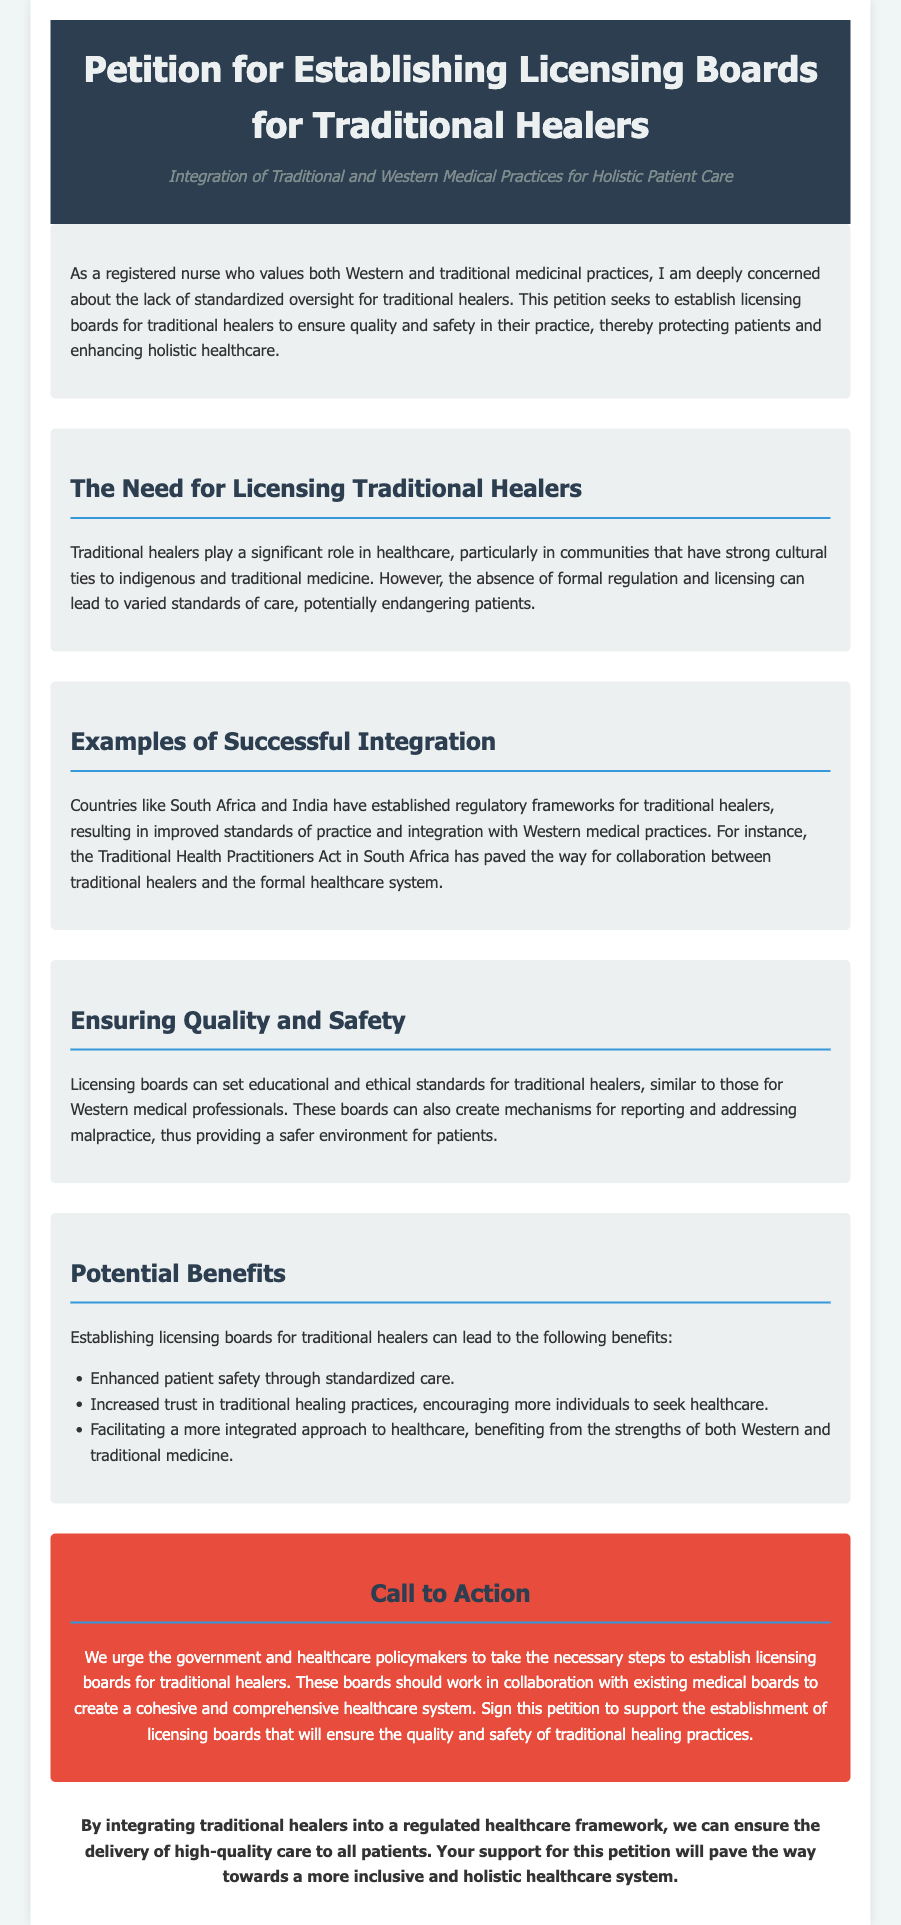What is the title of the petition? The title is the main heading of the document, which introduces the subject of the petition.
Answer: Petition for Establishing Licensing Boards for Traditional Healers What is the subtitle of the petition? The subtitle provides additional context about the purpose and perspective of the petition.
Answer: Integration of Traditional and Western Medical Practices for Holistic Patient Care Which countries are mentioned as examples of successful integration? The document provides specific examples of countries that have regulatory frameworks for traditional healers.
Answer: South Africa and India What act is referenced in South Africa concerning traditional health practitioners? The act is a specific legislative measure that has impacted the practice of traditional health practitioners in South Africa.
Answer: Traditional Health Practitioners Act How many potential benefits are listed in the document? The document outlines specific advantages of establishing licensing boards for traditional healers.
Answer: Three What is the primary goal of the licensing boards for traditional healers? The primary goal is the fundamental purpose or intention behind establishing these boards as stated in the petition.
Answer: Ensure quality and safety Who is urged to establish licensing boards according to the call to action? This identifies the targeted audience for the petition's proposal for action.
Answer: Government and healthcare policymakers What should the licensing boards create to enhance patient safety? This question focuses on the specific measures that are considered necessary to improve patient safety as per the document.
Answer: Mechanisms for reporting and addressing malpractice 